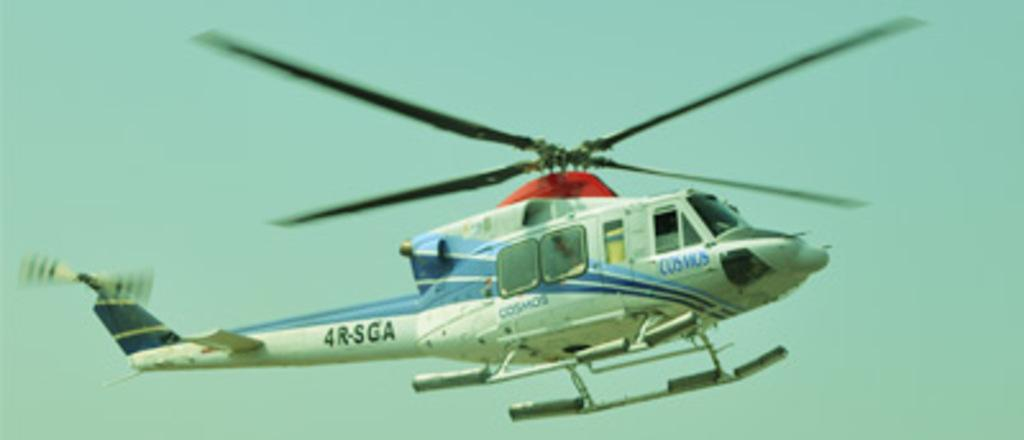What is the color of the plane in the image? The plane in the image is white. What can be seen in the background of the image? The sky is visible in the image. How many rings are visible on the plane in the image? There are no rings visible on the plane in the image. Is there a spy observing the plane in the image? There is no indication of a spy or any person in the image; it only shows a white color plane and the sky. 